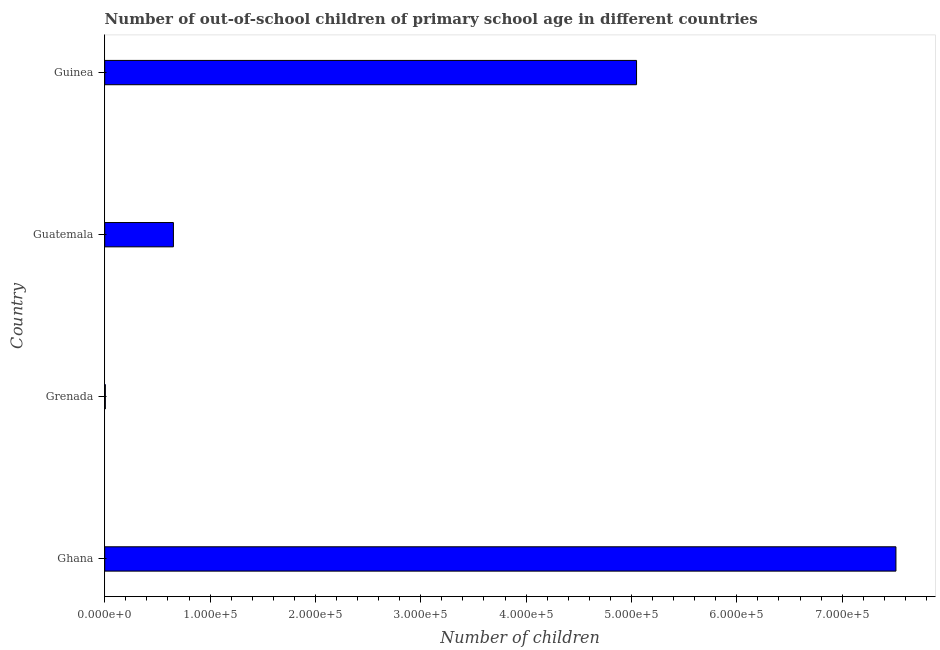Does the graph contain grids?
Offer a terse response. No. What is the title of the graph?
Provide a short and direct response. Number of out-of-school children of primary school age in different countries. What is the label or title of the X-axis?
Offer a terse response. Number of children. What is the label or title of the Y-axis?
Make the answer very short. Country. What is the number of out-of-school children in Ghana?
Make the answer very short. 7.51e+05. Across all countries, what is the maximum number of out-of-school children?
Your answer should be very brief. 7.51e+05. Across all countries, what is the minimum number of out-of-school children?
Provide a short and direct response. 586. In which country was the number of out-of-school children minimum?
Your answer should be compact. Grenada. What is the sum of the number of out-of-school children?
Your answer should be compact. 1.32e+06. What is the difference between the number of out-of-school children in Grenada and Guatemala?
Offer a very short reply. -6.46e+04. What is the average number of out-of-school children per country?
Make the answer very short. 3.30e+05. What is the median number of out-of-school children?
Offer a very short reply. 2.85e+05. What is the ratio of the number of out-of-school children in Grenada to that in Guatemala?
Give a very brief answer. 0.01. What is the difference between the highest and the second highest number of out-of-school children?
Your response must be concise. 2.46e+05. What is the difference between the highest and the lowest number of out-of-school children?
Provide a succinct answer. 7.50e+05. In how many countries, is the number of out-of-school children greater than the average number of out-of-school children taken over all countries?
Provide a short and direct response. 2. How many bars are there?
Ensure brevity in your answer.  4. Are all the bars in the graph horizontal?
Your response must be concise. Yes. How many countries are there in the graph?
Offer a very short reply. 4. What is the difference between two consecutive major ticks on the X-axis?
Ensure brevity in your answer.  1.00e+05. Are the values on the major ticks of X-axis written in scientific E-notation?
Make the answer very short. Yes. What is the Number of children in Ghana?
Offer a very short reply. 7.51e+05. What is the Number of children in Grenada?
Ensure brevity in your answer.  586. What is the Number of children in Guatemala?
Provide a short and direct response. 6.52e+04. What is the Number of children of Guinea?
Keep it short and to the point. 5.05e+05. What is the difference between the Number of children in Ghana and Grenada?
Offer a terse response. 7.50e+05. What is the difference between the Number of children in Ghana and Guatemala?
Keep it short and to the point. 6.86e+05. What is the difference between the Number of children in Ghana and Guinea?
Your response must be concise. 2.46e+05. What is the difference between the Number of children in Grenada and Guatemala?
Offer a very short reply. -6.46e+04. What is the difference between the Number of children in Grenada and Guinea?
Provide a succinct answer. -5.04e+05. What is the difference between the Number of children in Guatemala and Guinea?
Offer a terse response. -4.40e+05. What is the ratio of the Number of children in Ghana to that in Grenada?
Your response must be concise. 1281.68. What is the ratio of the Number of children in Ghana to that in Guatemala?
Give a very brief answer. 11.52. What is the ratio of the Number of children in Ghana to that in Guinea?
Give a very brief answer. 1.49. What is the ratio of the Number of children in Grenada to that in Guatemala?
Offer a very short reply. 0.01. What is the ratio of the Number of children in Guatemala to that in Guinea?
Keep it short and to the point. 0.13. 